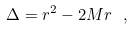<formula> <loc_0><loc_0><loc_500><loc_500>\Delta = r ^ { 2 } - 2 M r \ ,</formula> 